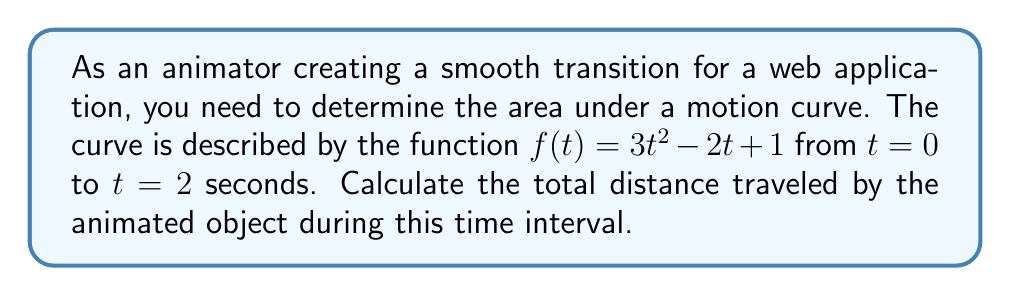What is the answer to this math problem? To find the total distance traveled, we need to calculate the area under the curve $f(t) = 3t^2 - 2t + 1$ from $t = 0$ to $t = 2$. This can be done using definite integration.

Step 1: Set up the definite integral
$$\int_0^2 (3t^2 - 2t + 1) dt$$

Step 2: Integrate the function
$$\left[\frac{3t^3}{3} - \frac{2t^2}{2} + t\right]_0^2$$

Step 3: Evaluate the integral at the upper and lower bounds
Upper bound (t = 2):
$$\frac{3(2^3)}{3} - \frac{2(2^2)}{2} + 2 = 8 - 4 + 2 = 6$$

Lower bound (t = 0):
$$\frac{3(0^3)}{3} - \frac{2(0^2)}{2} + 0 = 0$$

Step 4: Subtract the lower bound result from the upper bound result
$$6 - 0 = 6$$

Therefore, the total distance traveled by the animated object is 6 units.
Answer: 6 units 